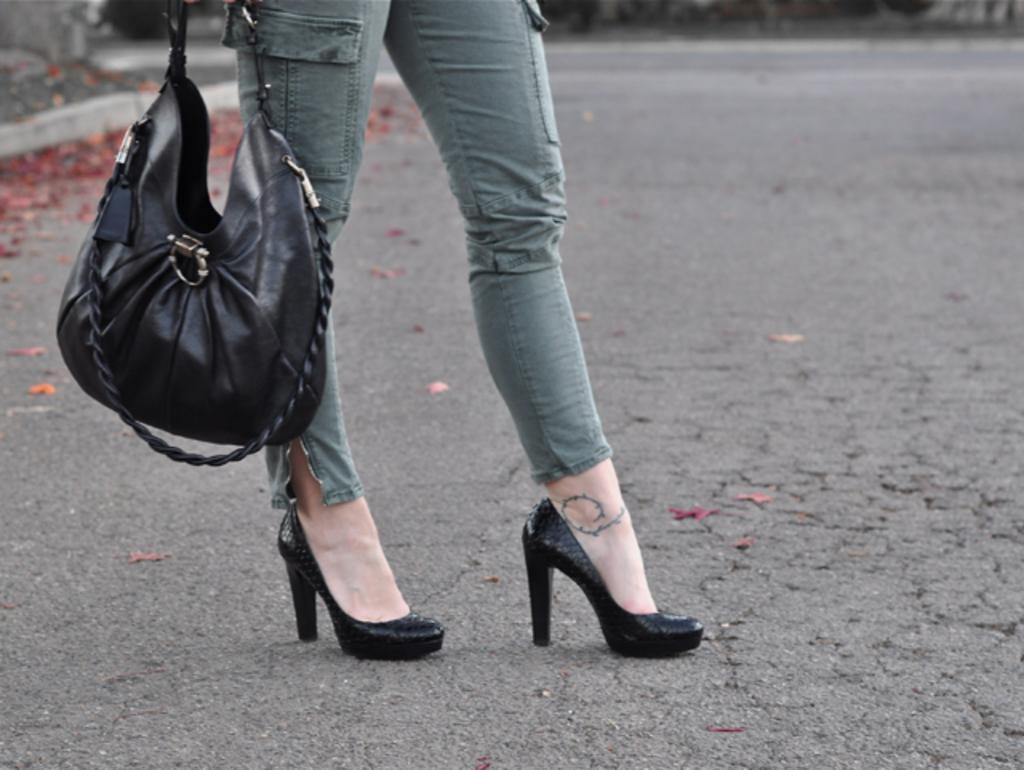How would you summarize this image in a sentence or two? The legs of a lady is shown in this picture with a handbag. The lady is wearing a high heels shoes. In the background we observe few red flowers on the ground. 